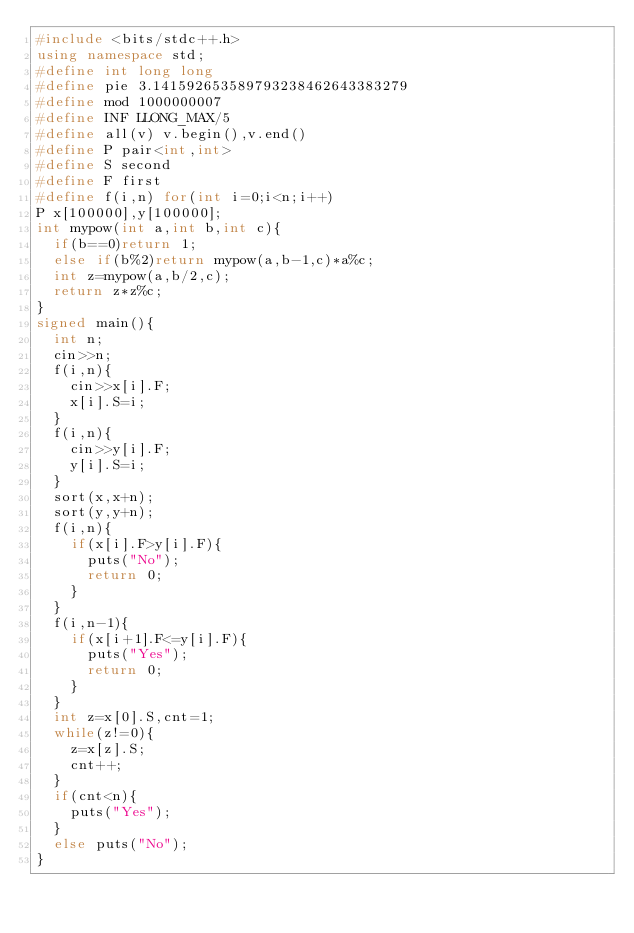Convert code to text. <code><loc_0><loc_0><loc_500><loc_500><_C++_>#include <bits/stdc++.h>
using namespace std;
#define int long long
#define pie 3.141592653589793238462643383279
#define mod 1000000007
#define INF LLONG_MAX/5
#define all(v) v.begin(),v.end()
#define P pair<int,int>
#define S second
#define F first
#define f(i,n) for(int i=0;i<n;i++)
P x[100000],y[100000];
int mypow(int a,int b,int c){
	if(b==0)return 1;
	else if(b%2)return mypow(a,b-1,c)*a%c;
	int z=mypow(a,b/2,c);
	return z*z%c;
}
signed main(){
	int n;
	cin>>n;
	f(i,n){
		cin>>x[i].F;
		x[i].S=i;
	}
	f(i,n){
		cin>>y[i].F;
		y[i].S=i;
	}
	sort(x,x+n);
	sort(y,y+n);
	f(i,n){
		if(x[i].F>y[i].F){
			puts("No");
			return 0;
		}
	}
	f(i,n-1){
		if(x[i+1].F<=y[i].F){
			puts("Yes");
			return 0;
		}
	}
	int z=x[0].S,cnt=1;
	while(z!=0){
		z=x[z].S;
		cnt++;
	}
	if(cnt<n){
		puts("Yes");
	}
	else puts("No");
}
</code> 